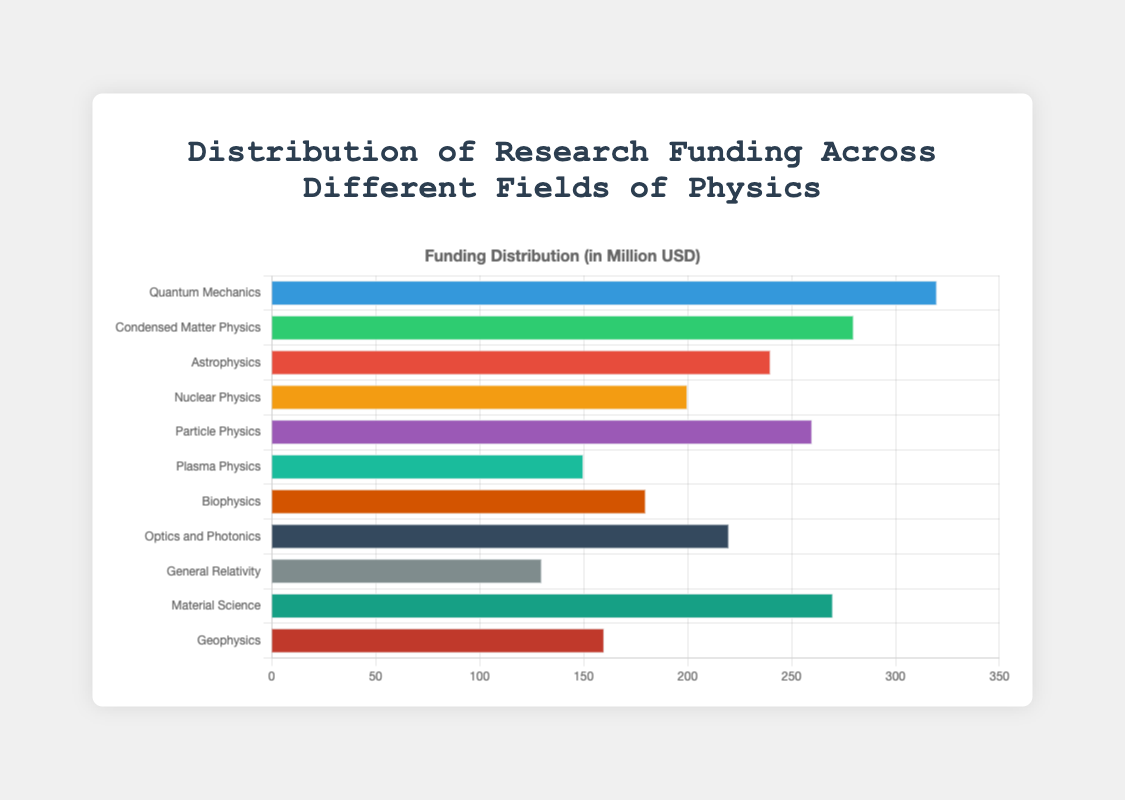What field of physics receives the highest amount of research funding? The tallest bar in the chart represents the field with the highest funding, which is "Quantum Mechanics," with 320 million USD.
Answer: Quantum Mechanics Which field of physics receives the least amount of research funding? The shortest bar in the chart represents the field with the least funding, which is "General Relativity," with 130 million USD.
Answer: General Relativity How much more research funding does Quantum Mechanics receive compared to Nuclear Physics? Quantum Mechanics receives 320 million USD, and Nuclear Physics receives 200 million USD. The difference is 320 - 200 = 120 million USD.
Answer: 120 million USD What is the total research funding for Astrophysics, Nuclear Physics, and Biophysics combined? The funding for Astrophysics (240 million USD), Nuclear Physics (200 million USD), and Biophysics (180 million USD) combines to 240 + 200 + 180 = 620 million USD.
Answer: 620 million USD Which fields of physics receive more than 250 million USD in research funding? The fields with bars extending beyond 250 million USD are: "Quantum Mechanics" (320 million USD), "Condensed Matter Physics" (280 million USD), "Particle Physics" (260 million USD), and "Material Science" (270 million USD).
Answer: Quantum Mechanics, Condensed Matter Physics, Particle Physics, Material Science How does the research funding for Plasma Physics compare to that for Geophysics? Plasma Physics has a shorter bar compared to Geophysics; Plasma Physics receives 150 million USD, while Geophysics receives 160 million USD.
Answer: Geophysics > Plasma Physics What is the average research funding for all the fields of physics shown in the chart? Summing up the funding amounts for all fields (320 + 280 + 240 + 200 + 260 + 150 + 180 + 220 + 130 + 270 + 160) gives 2410 million USD, and there are 11 fields. The average funding is 2410 / 11 = 219 million USD.
Answer: 219 million USD Which field of physics receives 220 million USD in research funding, and what is its position in terms of funding amount? The bar representing "Optics and Photonics" shows a funding of 220 million USD. By identifying the position from highest to lowest, "Optics and Photonics" is ranked 6th.
Answer: Optics and Photonics, 6th What is the total research funding for fields that receive less than 200 million USD each? Fields with less than 200 million USD are Plasma Physics (150 million USD), Biophysics (180 million USD), General Relativity (130 million USD), and Geophysics (160 million USD). Summing these: 150 + 180 + 130 + 160 = 620 million USD.
Answer: 620 million USD 